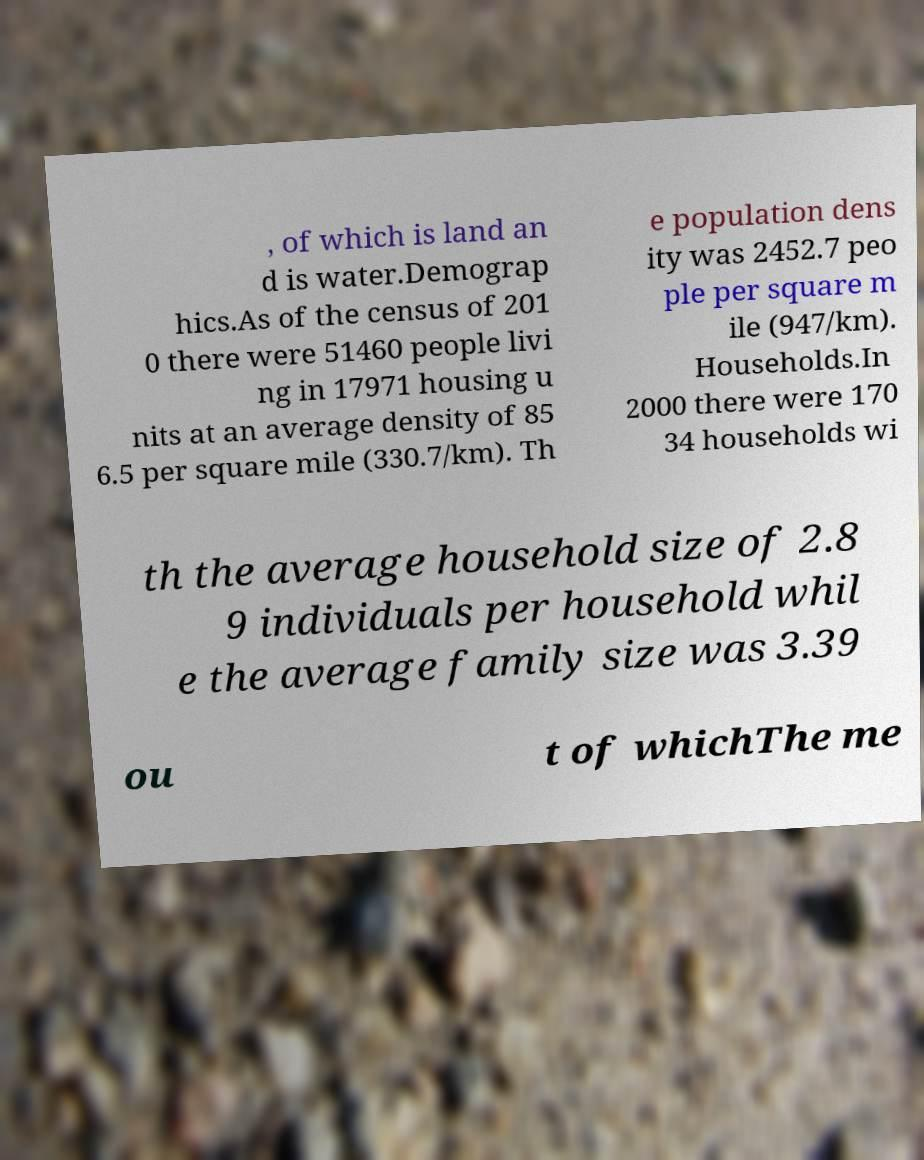There's text embedded in this image that I need extracted. Can you transcribe it verbatim? , of which is land an d is water.Demograp hics.As of the census of 201 0 there were 51460 people livi ng in 17971 housing u nits at an average density of 85 6.5 per square mile (330.7/km). Th e population dens ity was 2452.7 peo ple per square m ile (947/km). Households.In 2000 there were 170 34 households wi th the average household size of 2.8 9 individuals per household whil e the average family size was 3.39 ou t of whichThe me 